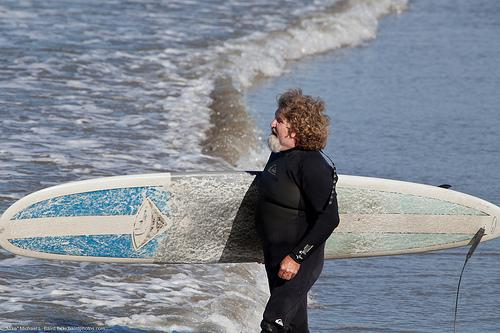Question: who is holding a surfboard?
Choices:
A. The surf instructor.
B. A woman.
C. The man.
D. The three kids.
Answer with the letter. Answer: C Question: what is the man holding?
Choices:
A. A surfboard.
B. A beer.
C. A briefcase.
D. His girlfriend's hand.
Answer with the letter. Answer: A Question: where is the picture taken?
Choices:
A. Antarctica.
B. The ocean.
C. At the museum.
D. In a nightclub.
Answer with the letter. Answer: B Question: what color is the man's surfboard?
Choices:
A. White and blue.
B. Black.
C. Brown.
D. Red.
Answer with the letter. Answer: A 